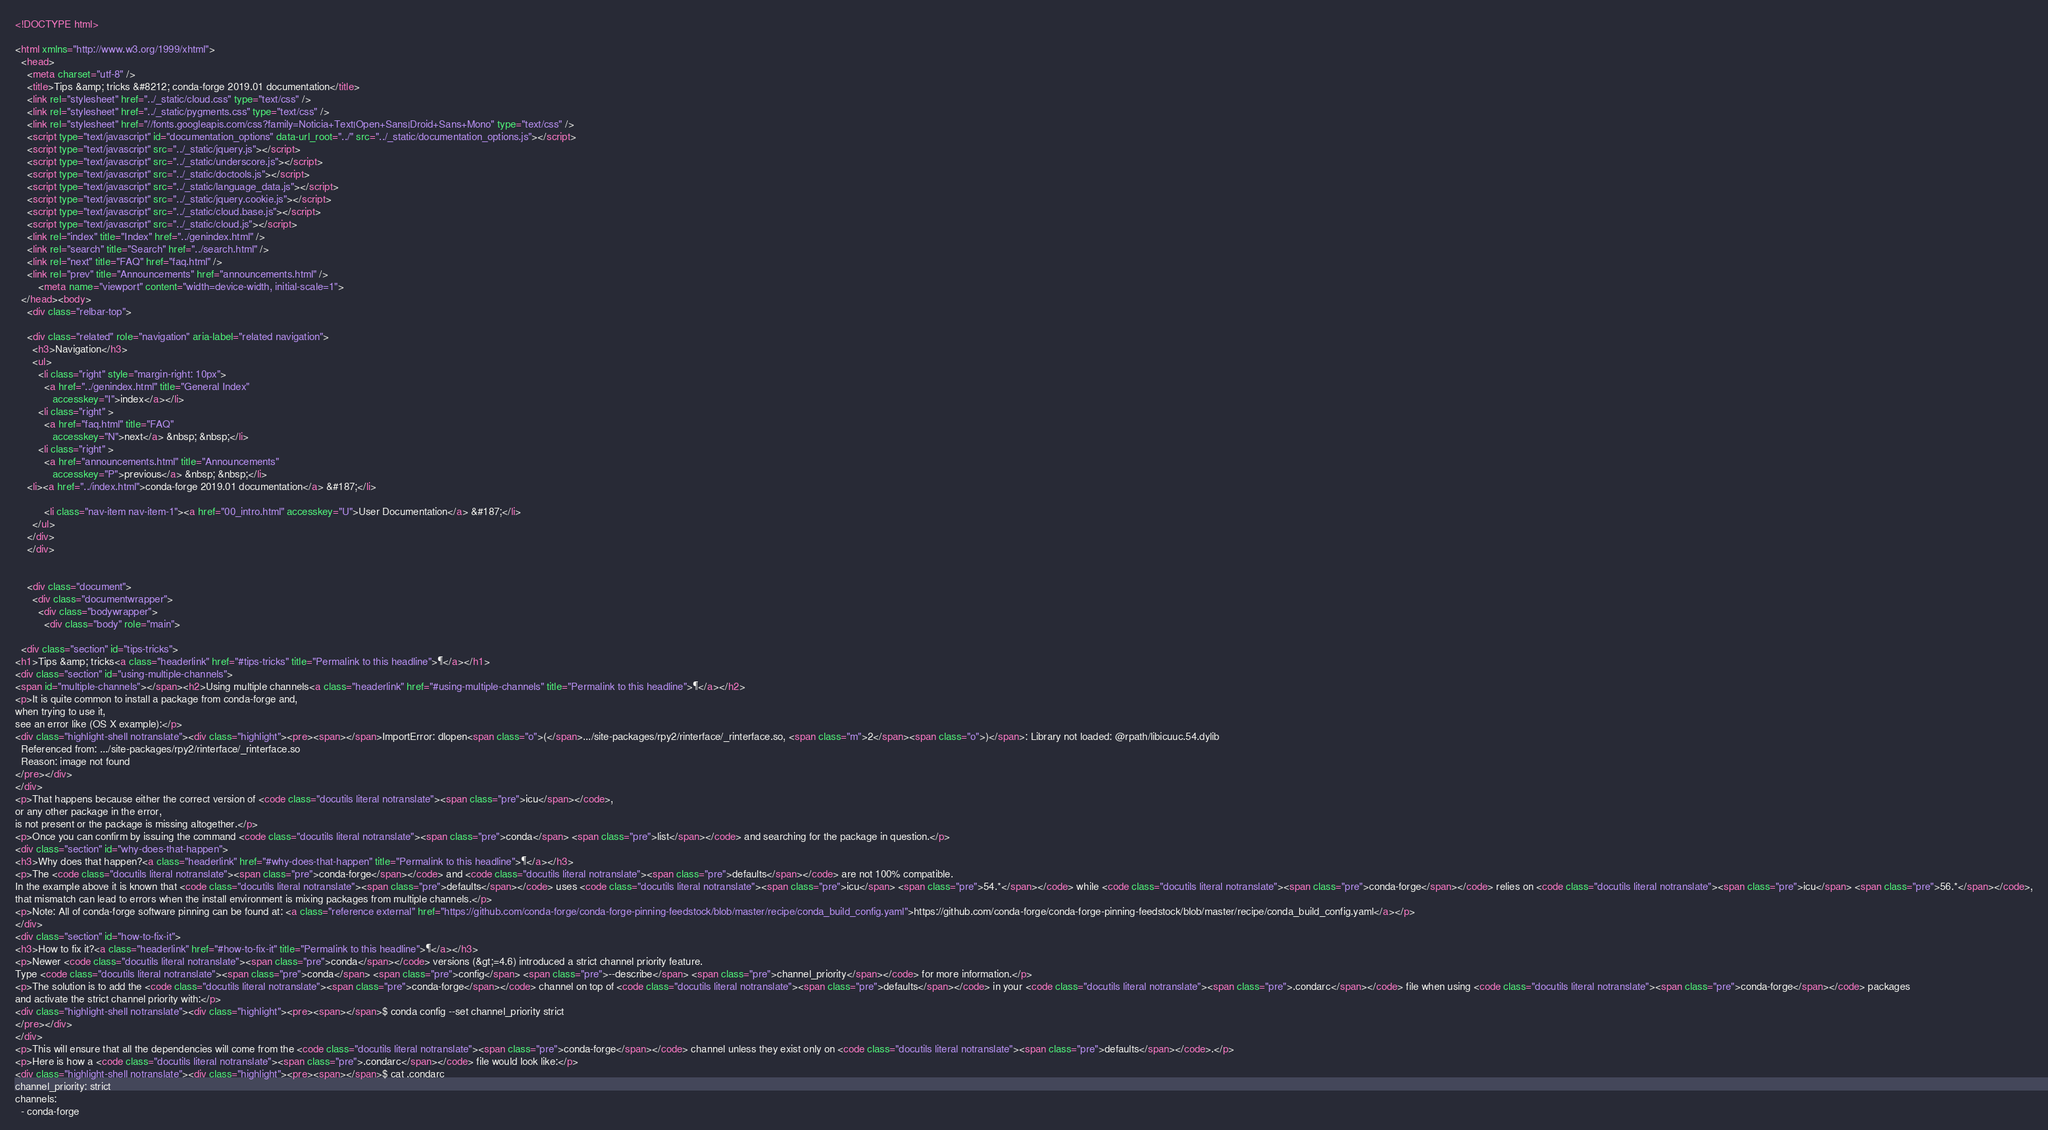Convert code to text. <code><loc_0><loc_0><loc_500><loc_500><_HTML_>


<!DOCTYPE html>

<html xmlns="http://www.w3.org/1999/xhtml">
  <head>
    <meta charset="utf-8" />
    <title>Tips &amp; tricks &#8212; conda-forge 2019.01 documentation</title>
    <link rel="stylesheet" href="../_static/cloud.css" type="text/css" />
    <link rel="stylesheet" href="../_static/pygments.css" type="text/css" />
    <link rel="stylesheet" href="//fonts.googleapis.com/css?family=Noticia+Text|Open+Sans|Droid+Sans+Mono" type="text/css" />
    <script type="text/javascript" id="documentation_options" data-url_root="../" src="../_static/documentation_options.js"></script>
    <script type="text/javascript" src="../_static/jquery.js"></script>
    <script type="text/javascript" src="../_static/underscore.js"></script>
    <script type="text/javascript" src="../_static/doctools.js"></script>
    <script type="text/javascript" src="../_static/language_data.js"></script>
    <script type="text/javascript" src="../_static/jquery.cookie.js"></script>
    <script type="text/javascript" src="../_static/cloud.base.js"></script>
    <script type="text/javascript" src="../_static/cloud.js"></script>
    <link rel="index" title="Index" href="../genindex.html" />
    <link rel="search" title="Search" href="../search.html" />
    <link rel="next" title="FAQ" href="faq.html" />
    <link rel="prev" title="Announcements" href="announcements.html" /> 
        <meta name="viewport" content="width=device-width, initial-scale=1">
  </head><body>
    <div class="relbar-top">
        
    <div class="related" role="navigation" aria-label="related navigation">
      <h3>Navigation</h3>
      <ul>
        <li class="right" style="margin-right: 10px">
          <a href="../genindex.html" title="General Index"
             accesskey="I">index</a></li>
        <li class="right" >
          <a href="faq.html" title="FAQ"
             accesskey="N">next</a> &nbsp; &nbsp;</li>
        <li class="right" >
          <a href="announcements.html" title="Announcements"
             accesskey="P">previous</a> &nbsp; &nbsp;</li>
    <li><a href="../index.html">conda-forge 2019.01 documentation</a> &#187;</li>

          <li class="nav-item nav-item-1"><a href="00_intro.html" accesskey="U">User Documentation</a> &#187;</li> 
      </ul>
    </div>
    </div>
  

    <div class="document">
      <div class="documentwrapper">
        <div class="bodywrapper">
          <div class="body" role="main">
            
  <div class="section" id="tips-tricks">
<h1>Tips &amp; tricks<a class="headerlink" href="#tips-tricks" title="Permalink to this headline">¶</a></h1>
<div class="section" id="using-multiple-channels">
<span id="multiple-channels"></span><h2>Using multiple channels<a class="headerlink" href="#using-multiple-channels" title="Permalink to this headline">¶</a></h2>
<p>It is quite common to install a package from conda-forge and,
when trying to use it,
see an error like (OS X example):</p>
<div class="highlight-shell notranslate"><div class="highlight"><pre><span></span>ImportError: dlopen<span class="o">(</span>.../site-packages/rpy2/rinterface/_rinterface.so, <span class="m">2</span><span class="o">)</span>: Library not loaded: @rpath/libicuuc.54.dylib
  Referenced from: .../site-packages/rpy2/rinterface/_rinterface.so
  Reason: image not found
</pre></div>
</div>
<p>That happens because either the correct version of <code class="docutils literal notranslate"><span class="pre">icu</span></code>,
or any other package in the error,
is not present or the package is missing altogether.</p>
<p>Once you can confirm by issuing the command <code class="docutils literal notranslate"><span class="pre">conda</span> <span class="pre">list</span></code> and searching for the package in question.</p>
<div class="section" id="why-does-that-happen">
<h3>Why does that happen?<a class="headerlink" href="#why-does-that-happen" title="Permalink to this headline">¶</a></h3>
<p>The <code class="docutils literal notranslate"><span class="pre">conda-forge</span></code> and <code class="docutils literal notranslate"><span class="pre">defaults</span></code> are not 100% compatible.
In the example above it is known that <code class="docutils literal notranslate"><span class="pre">defaults</span></code> uses <code class="docutils literal notranslate"><span class="pre">icu</span> <span class="pre">54.*</span></code> while <code class="docutils literal notranslate"><span class="pre">conda-forge</span></code> relies on <code class="docutils literal notranslate"><span class="pre">icu</span> <span class="pre">56.*</span></code>,
that mismatch can lead to errors when the install environment is mixing packages from multiple channels.</p>
<p>Note: All of conda-forge software pinning can be found at: <a class="reference external" href="https://github.com/conda-forge/conda-forge-pinning-feedstock/blob/master/recipe/conda_build_config.yaml">https://github.com/conda-forge/conda-forge-pinning-feedstock/blob/master/recipe/conda_build_config.yaml</a></p>
</div>
<div class="section" id="how-to-fix-it">
<h3>How to fix it?<a class="headerlink" href="#how-to-fix-it" title="Permalink to this headline">¶</a></h3>
<p>Newer <code class="docutils literal notranslate"><span class="pre">conda</span></code> versions (&gt;=4.6) introduced a strict channel priority feature.
Type <code class="docutils literal notranslate"><span class="pre">conda</span> <span class="pre">config</span> <span class="pre">--describe</span> <span class="pre">channel_priority</span></code> for more information.</p>
<p>The solution is to add the <code class="docutils literal notranslate"><span class="pre">conda-forge</span></code> channel on top of <code class="docutils literal notranslate"><span class="pre">defaults</span></code> in your <code class="docutils literal notranslate"><span class="pre">.condarc</span></code> file when using <code class="docutils literal notranslate"><span class="pre">conda-forge</span></code> packages
and activate the strict channel priority with:</p>
<div class="highlight-shell notranslate"><div class="highlight"><pre><span></span>$ conda config --set channel_priority strict
</pre></div>
</div>
<p>This will ensure that all the dependencies will come from the <code class="docutils literal notranslate"><span class="pre">conda-forge</span></code> channel unless they exist only on <code class="docutils literal notranslate"><span class="pre">defaults</span></code>.</p>
<p>Here is how a <code class="docutils literal notranslate"><span class="pre">.condarc</span></code> file would look like:</p>
<div class="highlight-shell notranslate"><div class="highlight"><pre><span></span>$ cat .condarc
channel_priority: strict
channels:
  - conda-forge</code> 